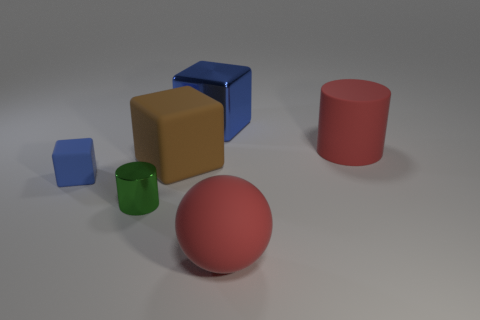Subtract all rubber cubes. How many cubes are left? 1 Subtract all red cylinders. How many cylinders are left? 1 Subtract all cylinders. How many objects are left? 4 Subtract 1 cylinders. How many cylinders are left? 1 Add 2 large brown shiny blocks. How many objects exist? 8 Subtract all cyan cylinders. How many yellow balls are left? 0 Subtract all large blue things. Subtract all red shiny cubes. How many objects are left? 5 Add 4 blue metal objects. How many blue metal objects are left? 5 Add 6 shiny things. How many shiny things exist? 8 Subtract 0 yellow cylinders. How many objects are left? 6 